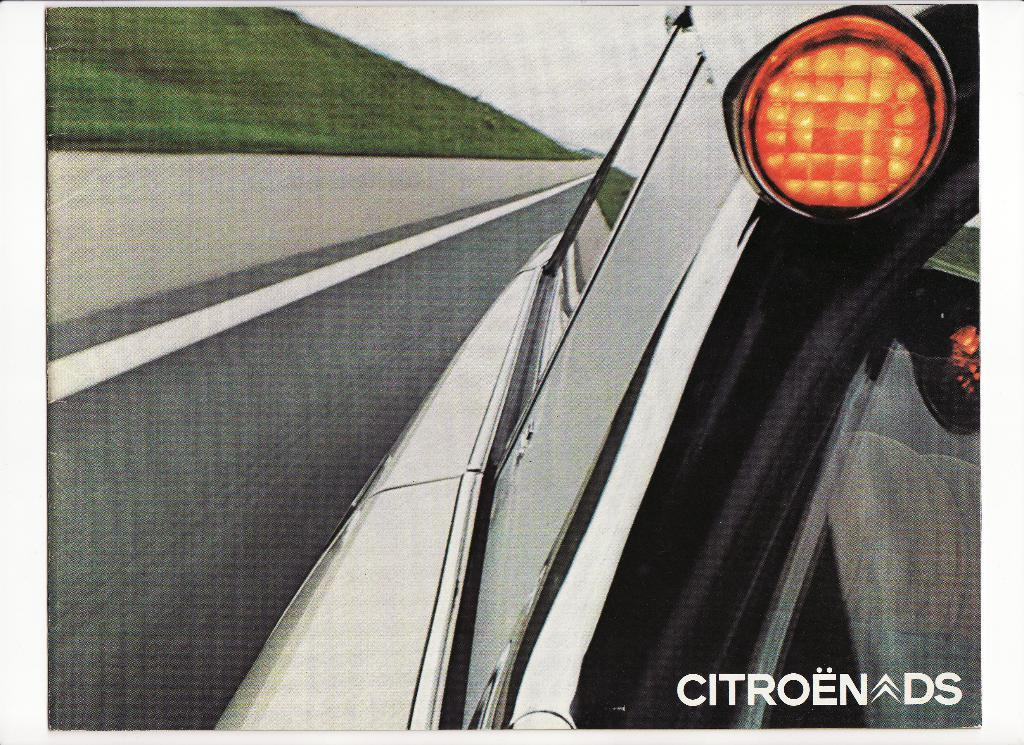What can be observed about the image itself? The image is edited. What is present on the road in the image? There is a vehicle on the road. What type of vegetation is visible in the image? There is grass visible in the image. What is visible in the background of the image? The sky is visible in the background of the image. What type of cake is being served in the image? There is no cake present in the image. Can you see someone's arm holding the vehicle in the image? There is no arm visible in the image, and the vehicle is not being held by anyone. 